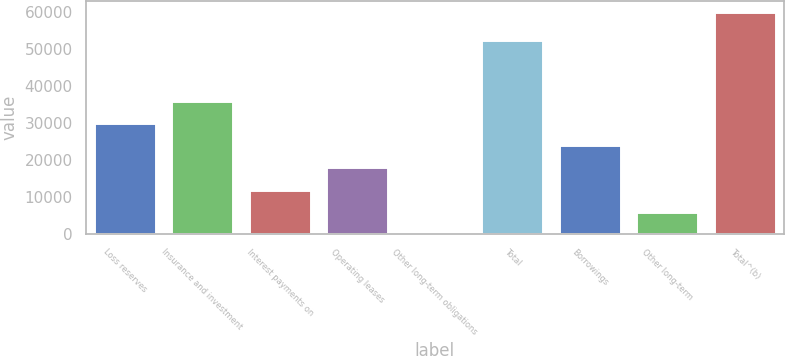Convert chart to OTSL. <chart><loc_0><loc_0><loc_500><loc_500><bar_chart><fcel>Loss reserves<fcel>Insurance and investment<fcel>Interest payments on<fcel>Operating leases<fcel>Other long-term obligations<fcel>Total<fcel>Borrowings<fcel>Other long-term<fcel>Total^(b)<nl><fcel>29989<fcel>35984.8<fcel>12001.6<fcel>17997.4<fcel>10<fcel>52313<fcel>23993.2<fcel>6005.8<fcel>59968<nl></chart> 